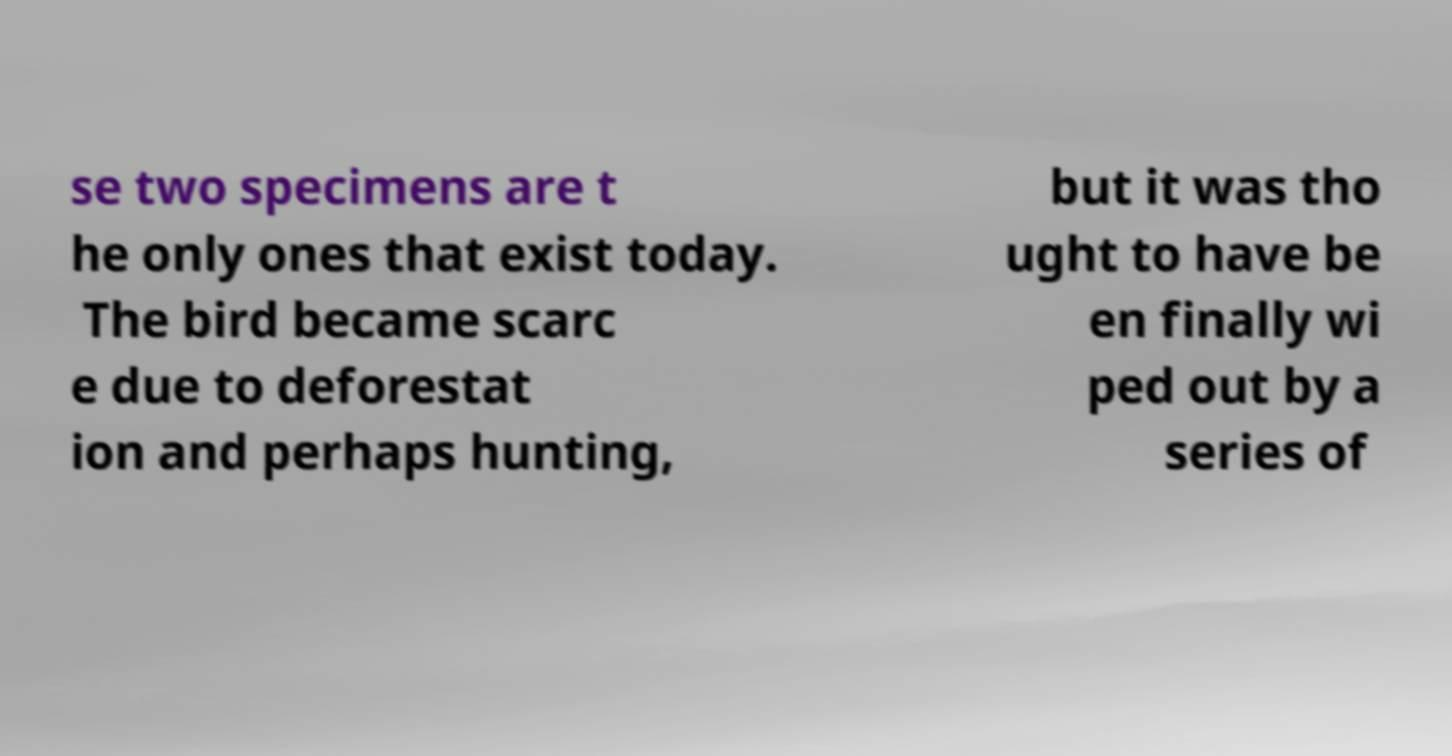I need the written content from this picture converted into text. Can you do that? se two specimens are t he only ones that exist today. The bird became scarc e due to deforestat ion and perhaps hunting, but it was tho ught to have be en finally wi ped out by a series of 